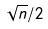<formula> <loc_0><loc_0><loc_500><loc_500>\sqrt { n } / 2</formula> 